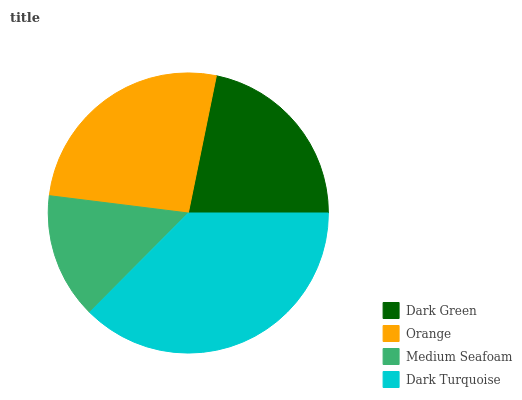Is Medium Seafoam the minimum?
Answer yes or no. Yes. Is Dark Turquoise the maximum?
Answer yes or no. Yes. Is Orange the minimum?
Answer yes or no. No. Is Orange the maximum?
Answer yes or no. No. Is Orange greater than Dark Green?
Answer yes or no. Yes. Is Dark Green less than Orange?
Answer yes or no. Yes. Is Dark Green greater than Orange?
Answer yes or no. No. Is Orange less than Dark Green?
Answer yes or no. No. Is Orange the high median?
Answer yes or no. Yes. Is Dark Green the low median?
Answer yes or no. Yes. Is Medium Seafoam the high median?
Answer yes or no. No. Is Orange the low median?
Answer yes or no. No. 